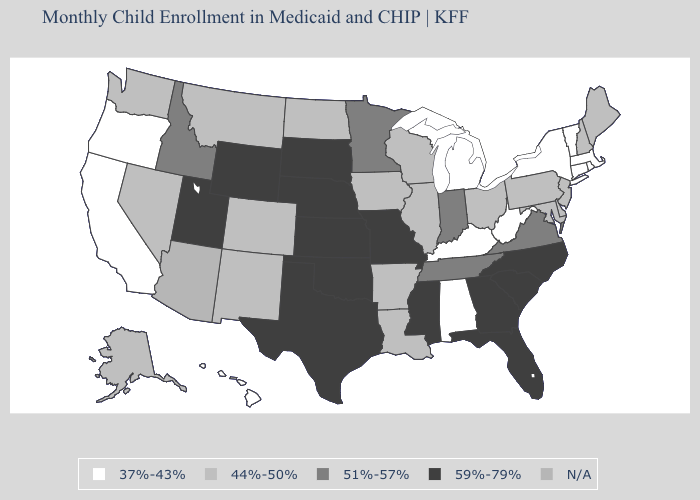What is the value of Arizona?
Short answer required. N/A. Name the states that have a value in the range 51%-57%?
Concise answer only. Idaho, Indiana, Minnesota, Tennessee, Virginia. Does Connecticut have the lowest value in the Northeast?
Keep it brief. Yes. Among the states that border Michigan , which have the lowest value?
Answer briefly. Ohio, Wisconsin. Does New Mexico have the lowest value in the West?
Concise answer only. No. What is the value of Kansas?
Give a very brief answer. 59%-79%. Which states have the lowest value in the USA?
Write a very short answer. Alabama, California, Connecticut, Hawaii, Kentucky, Massachusetts, Michigan, New York, Oregon, Rhode Island, Vermont, West Virginia. What is the lowest value in the MidWest?
Quick response, please. 37%-43%. Among the states that border Maine , which have the lowest value?
Give a very brief answer. New Hampshire. Name the states that have a value in the range 59%-79%?
Answer briefly. Florida, Georgia, Kansas, Mississippi, Missouri, Nebraska, North Carolina, Oklahoma, South Carolina, South Dakota, Texas, Utah, Wyoming. What is the lowest value in the USA?
Give a very brief answer. 37%-43%. What is the value of Mississippi?
Short answer required. 59%-79%. Among the states that border North Carolina , which have the lowest value?
Keep it brief. Tennessee, Virginia. What is the value of Idaho?
Write a very short answer. 51%-57%. 